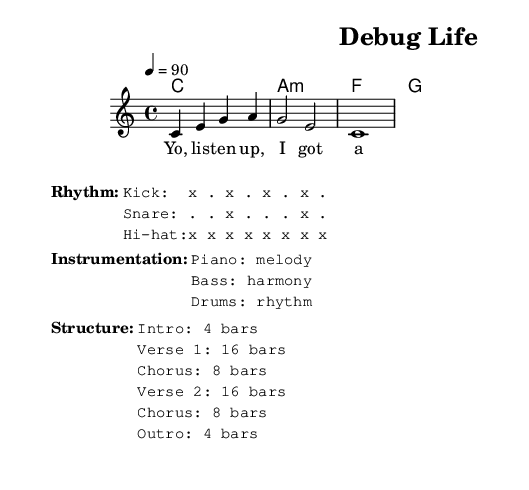What is the key signature of this music? The key signature is C major, which is indicated at the beginning of the global section. C major has no sharps or flats.
Answer: C major What is the time signature of this music? The time signature is displayed as 4/4 at the beginning in the global section, which indicates that there are four beats per measure.
Answer: 4/4 What is the tempo marking for this piece? The tempo marking is specified as "4 = 90" in the global section, indicating that there should be 90 beats per minute, with a quarter note receiving the beat.
Answer: 90 How many bars are in verse 1? Verse 1 is listed to have 16 bars according to the structure details provided in the markup section, which outlines the lengths of different sections.
Answer: 16 bars What is the dominant chord in the harmony section? The dominant chord is G major, which is the chord that appears third in the chord mode sequence. It typically functions as the V chord in the key of C major.
Answer: G What is the main theme of the lyrics? The lyrics start with "Yo, listen up, I got a tale to tell," indicating the theme is introducing a story, which aligns with the humorous rap parody about debugging code.
Answer: Tale to tell What is the instrumentation for the rhythm in this piece? The instrumentation for rhythm is designated as drums, which are detailed in the 'Instrumentation' markup section, indicating the role of rhythm in the composition.
Answer: Drums 